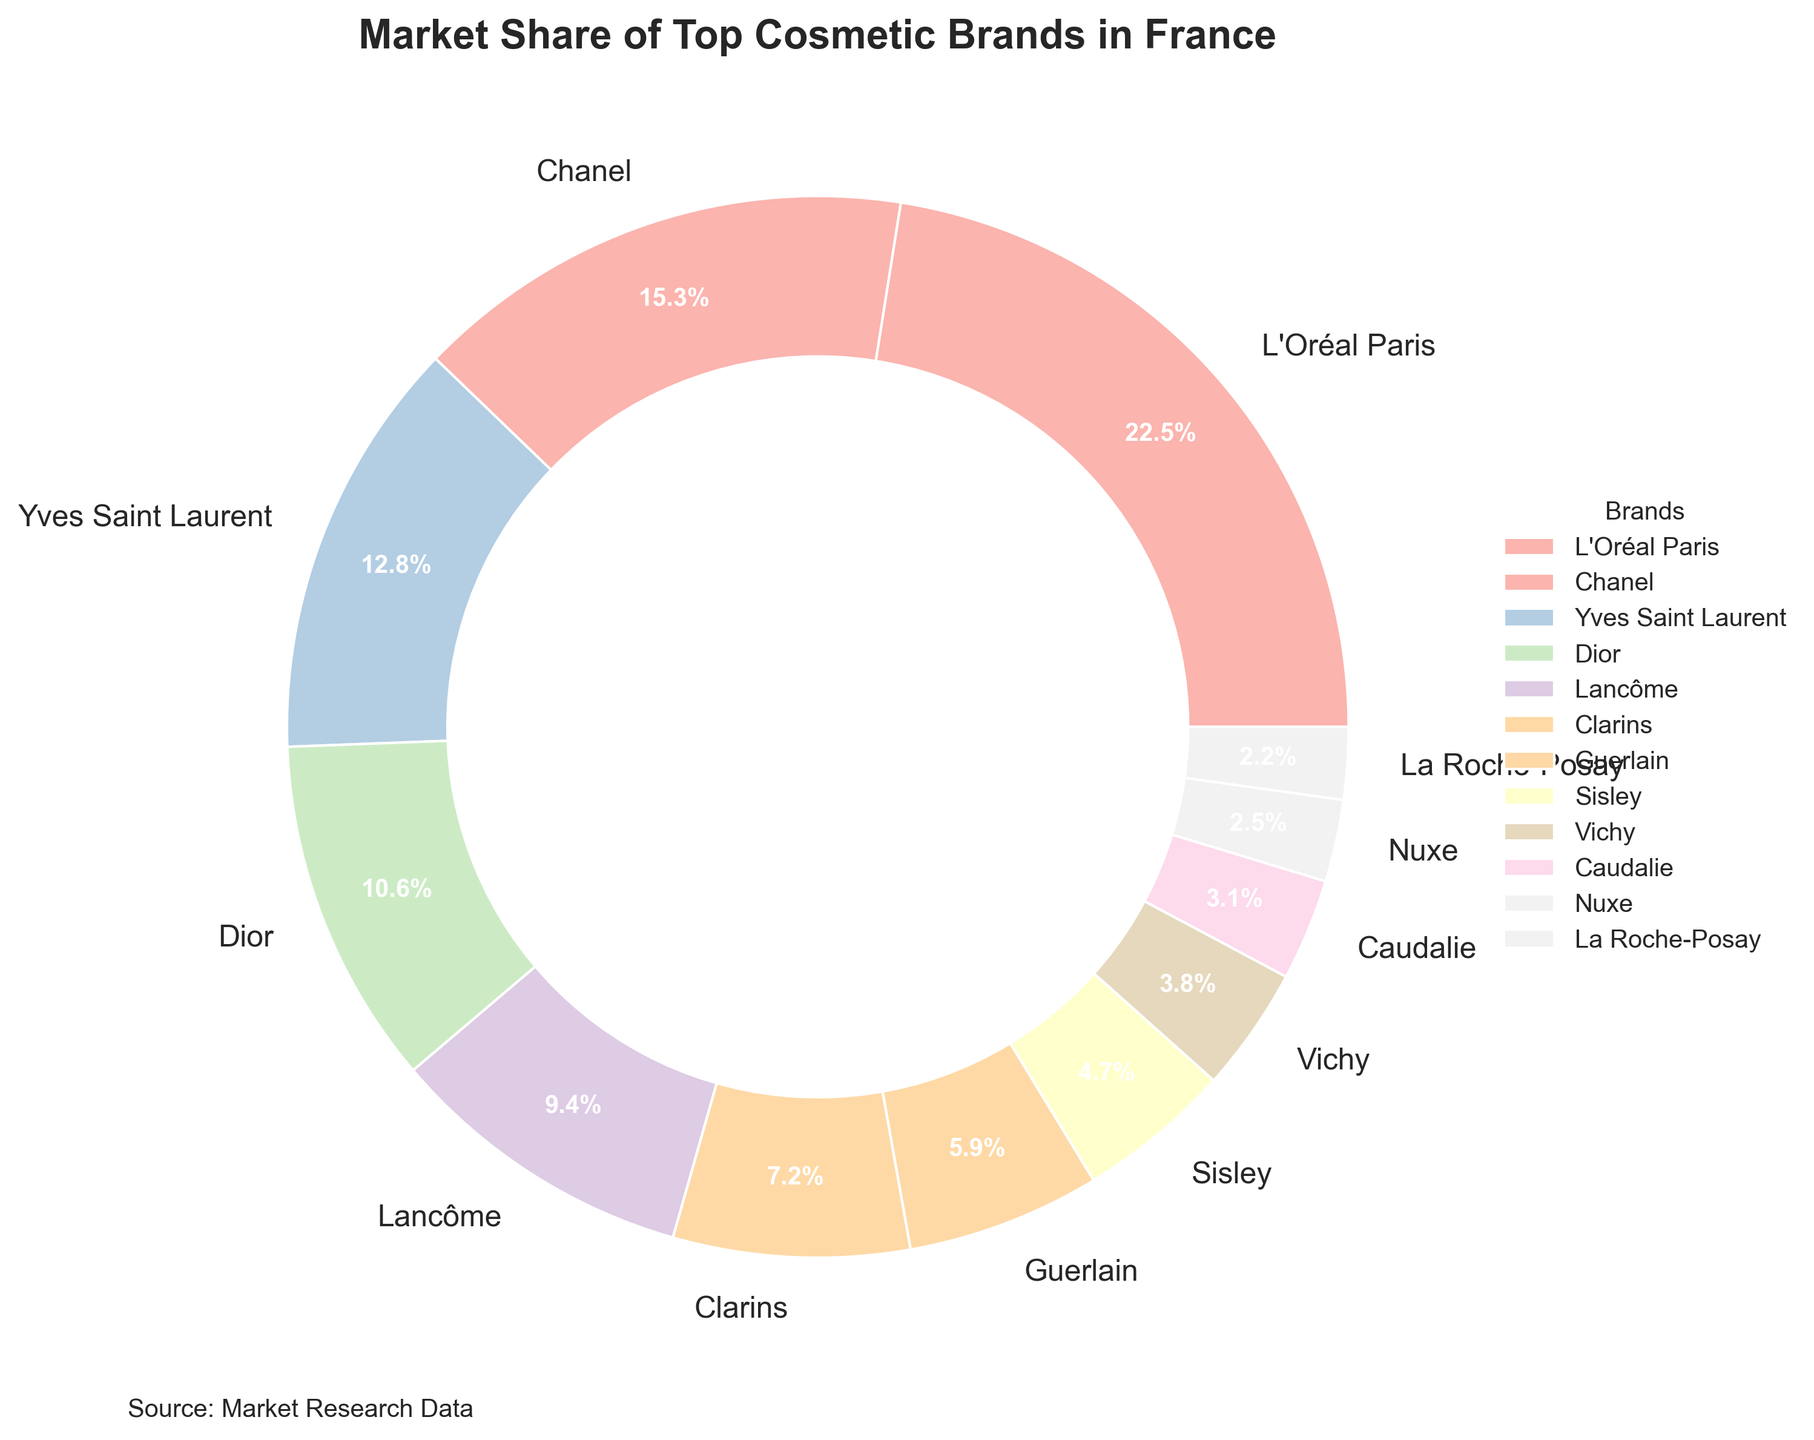Which brand has the largest market share? The brand with the largest percentage displayed inside the pie wedge is L'Oréal Paris.
Answer: L'Oréal Paris What is the combined market share of Chanel and Dior? The market share for Chanel is 15.3% and for Dior is 10.6%. Thus, the combined market share is 15.3% + 10.6% = 25.9%.
Answer: 25.9% Which brand has a smaller market share, Lancôme or Clarins? The market share for Lancôme is 9.4% and for Clarins is 7.2%. Since 9.4% is greater than 7.2%, Clarins has a smaller market share.
Answer: Clarins What is the market share difference between the brand with the highest share and the brand with the lowest share? The market share for L'Oréal Paris (the highest) is 22.5% and for La Roche-Posay (the lowest) is 2.2%. The difference is 22.5% - 2.2% = 20.3%.
Answer: 20.3% Are there any brands with a market share greater than 20%? If so, which one(s)? The only brand with a market share above 20% is L'Oréal Paris with 22.5%.
Answer: L'Oréal Paris How does the market share of Yves Saint Laurent compare to that of Lancôme? The market share for Yves Saint Laurent is 12.8%, and for Lancôme, it is 9.4%. Since 12.8% is greater than 9.4%, Yves Saint Laurent has a larger market share.
Answer: Yves Saint Laurent What percentage of the market is held by brands with a market share less than 5%? Brands with less than 5% market share are Guerlain (5.9%), Sisley (4.7%), Vichy (3.8%), Caudalie (3.1%), Nuxe (2.5%), and La Roche-Posay (2.2%). Adding these up: 4.7% + 3.8% + 3.1% + 2.5% + 2.2% = 16.3%.
Answer: 16.3% Which brands individually hold more than 10% of the market share? The brands holding more than 10% market share are L'Oréal Paris (22.5%), Chanel (15.3%), and Yves Saint Laurent (12.8%).
Answer: L'Oréal Paris, Chanel, Yves Saint Laurent What is the total market share of Lancôme, Clarins, and Guerlain? The market shares are: Lancôme 9.4%, Clarins 7.2%, and Guerlain 5.9%. Adding these up: 9.4% + 7.2% + 5.9% = 22.5%.
Answer: 22.5% Among Caudalie, Nuxe, and La Roche-Posay, which has the highest market share? Caudalie has a market share of 3.1%, Nuxe has 2.5%, and La Roche-Posay has 2.2%. Since 3.1% is the highest, Caudalie has the highest market share among these three brands.
Answer: Caudalie 